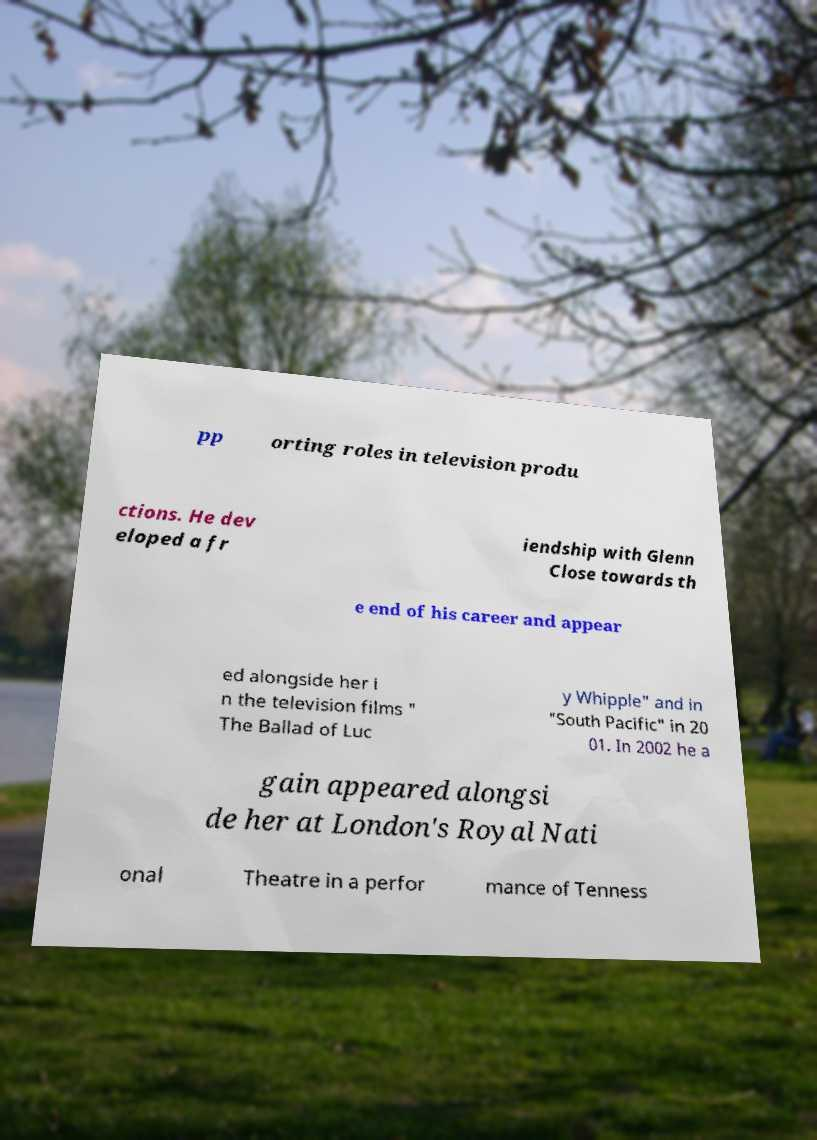What messages or text are displayed in this image? I need them in a readable, typed format. pp orting roles in television produ ctions. He dev eloped a fr iendship with Glenn Close towards th e end of his career and appear ed alongside her i n the television films " The Ballad of Luc y Whipple" and in "South Pacific" in 20 01. In 2002 he a gain appeared alongsi de her at London's Royal Nati onal Theatre in a perfor mance of Tenness 